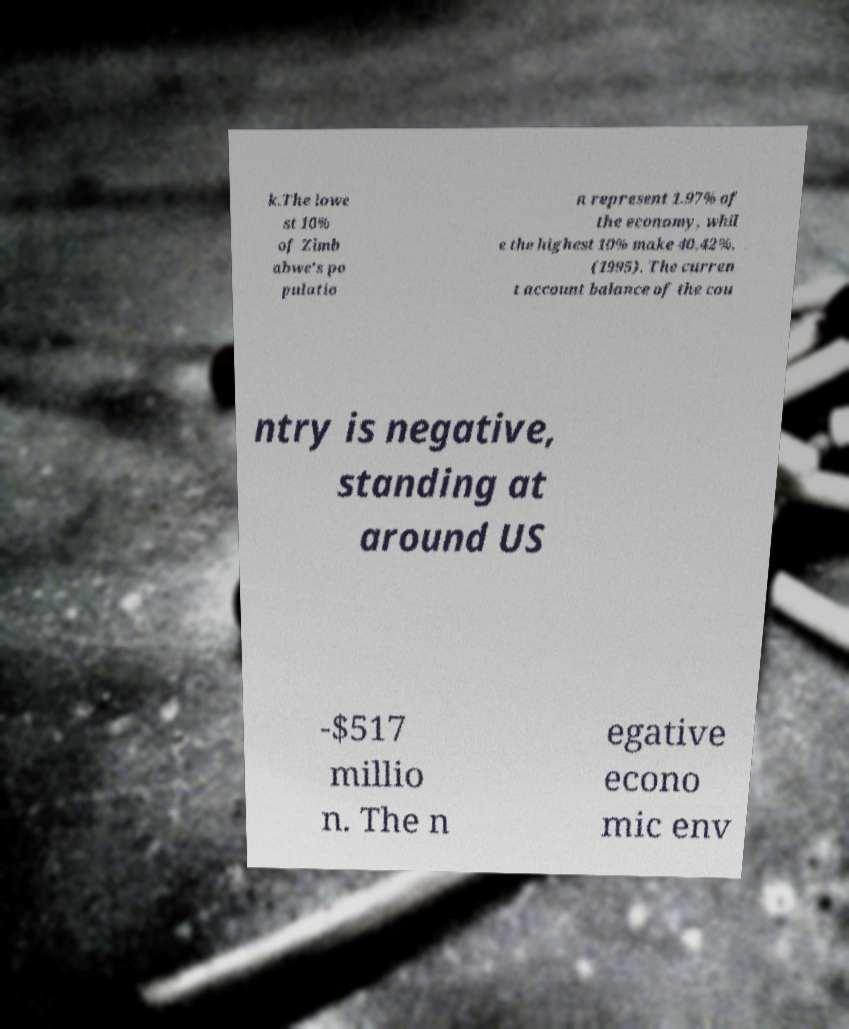What messages or text are displayed in this image? I need them in a readable, typed format. k.The lowe st 10% of Zimb abwe's po pulatio n represent 1.97% of the economy, whil e the highest 10% make 40.42%. (1995). The curren t account balance of the cou ntry is negative, standing at around US -$517 millio n. The n egative econo mic env 